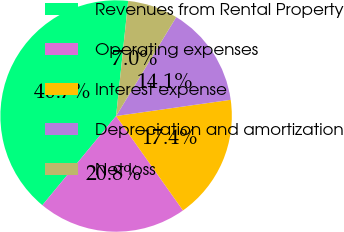Convert chart. <chart><loc_0><loc_0><loc_500><loc_500><pie_chart><fcel>Revenues from Rental Property<fcel>Operating expenses<fcel>Interest expense<fcel>Depreciation and amortization<fcel>Net loss<nl><fcel>40.67%<fcel>20.8%<fcel>17.43%<fcel>14.07%<fcel>7.03%<nl></chart> 